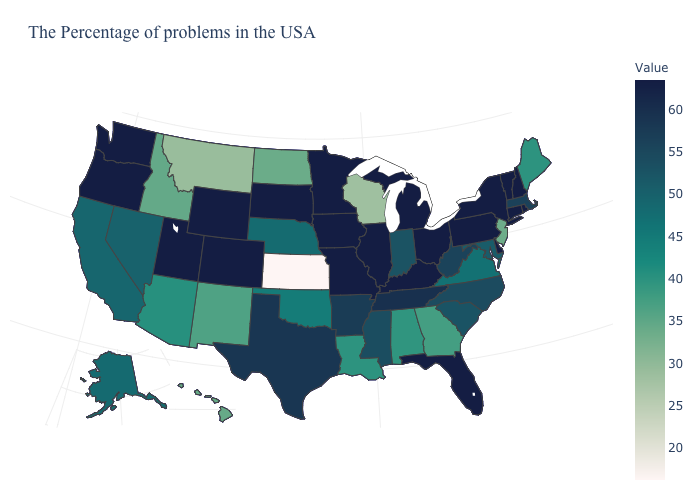Does the map have missing data?
Give a very brief answer. No. Does Kentucky have the highest value in the South?
Answer briefly. Yes. Does Maine have a higher value than Kansas?
Short answer required. Yes. Among the states that border Wisconsin , which have the highest value?
Be succinct. Michigan, Illinois, Minnesota, Iowa. Does Delaware have the lowest value in the USA?
Keep it brief. No. 